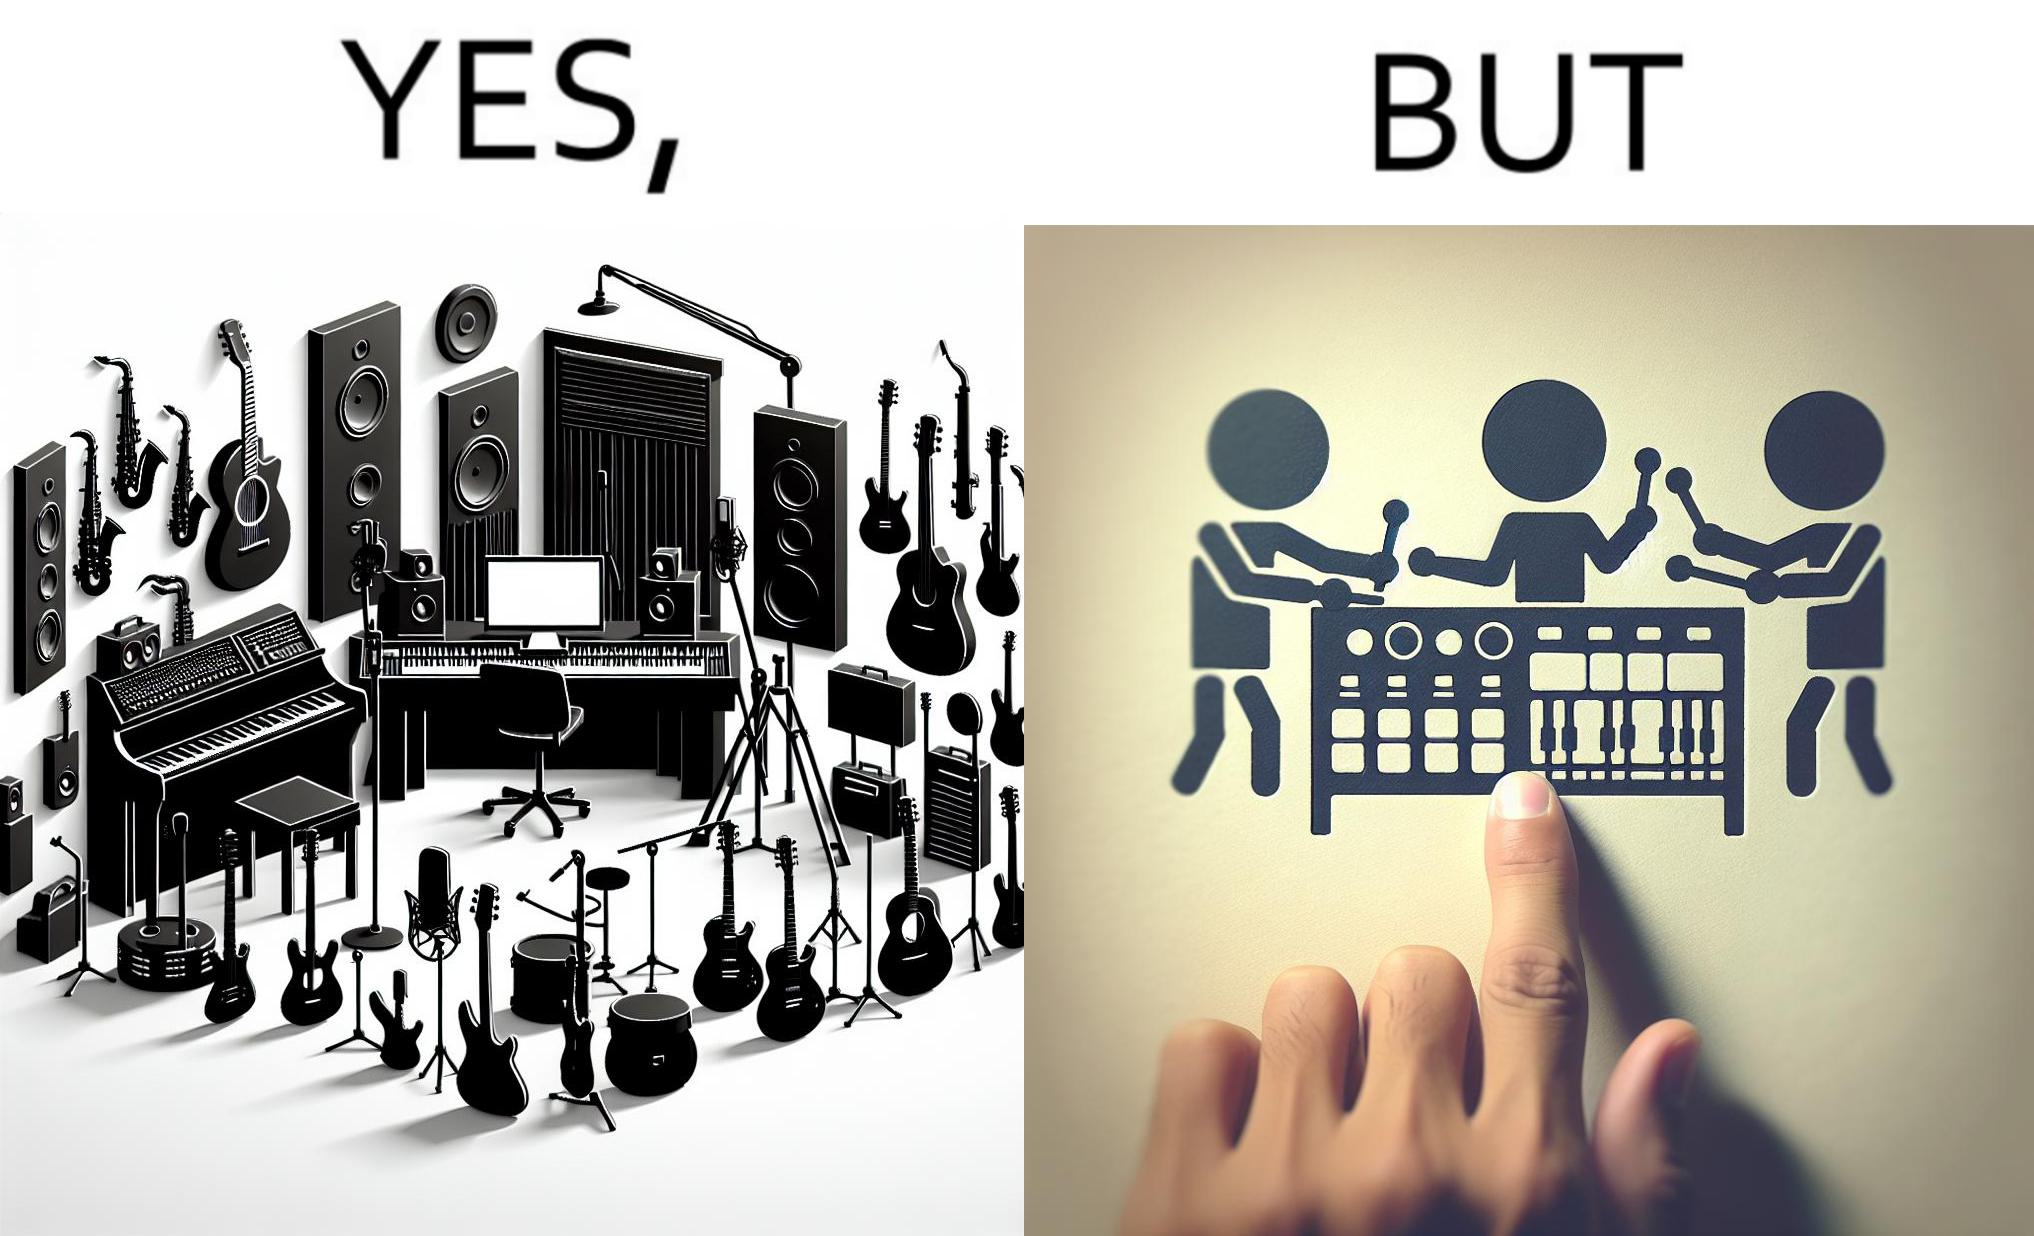What do you see in each half of this image? In the left part of the image: The image shows a music studio with differnt kinds of instruments like guitar and saxophone, piano and recording  to make music. In the right part of the image: The image shows the view of an electornic equipment used to create music. It has buttons to record, play drums and other musical instruments. 